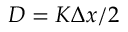<formula> <loc_0><loc_0><loc_500><loc_500>D = K \Delta x / 2</formula> 